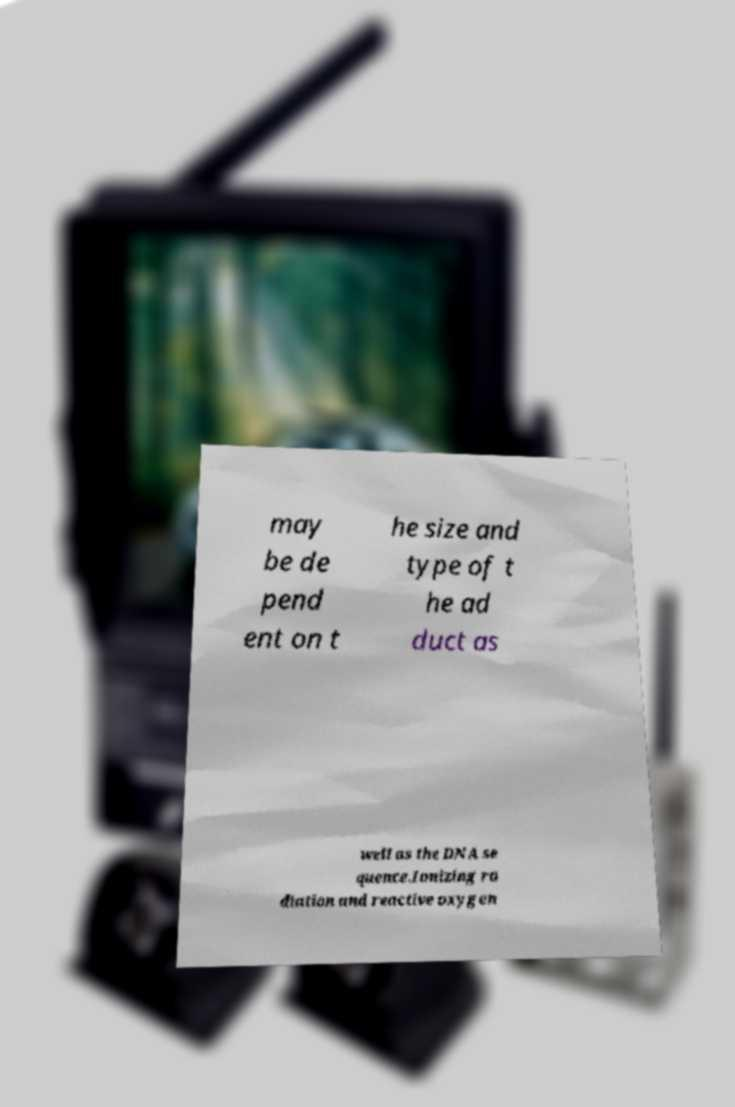Please read and relay the text visible in this image. What does it say? may be de pend ent on t he size and type of t he ad duct as well as the DNA se quence.Ionizing ra diation and reactive oxygen 